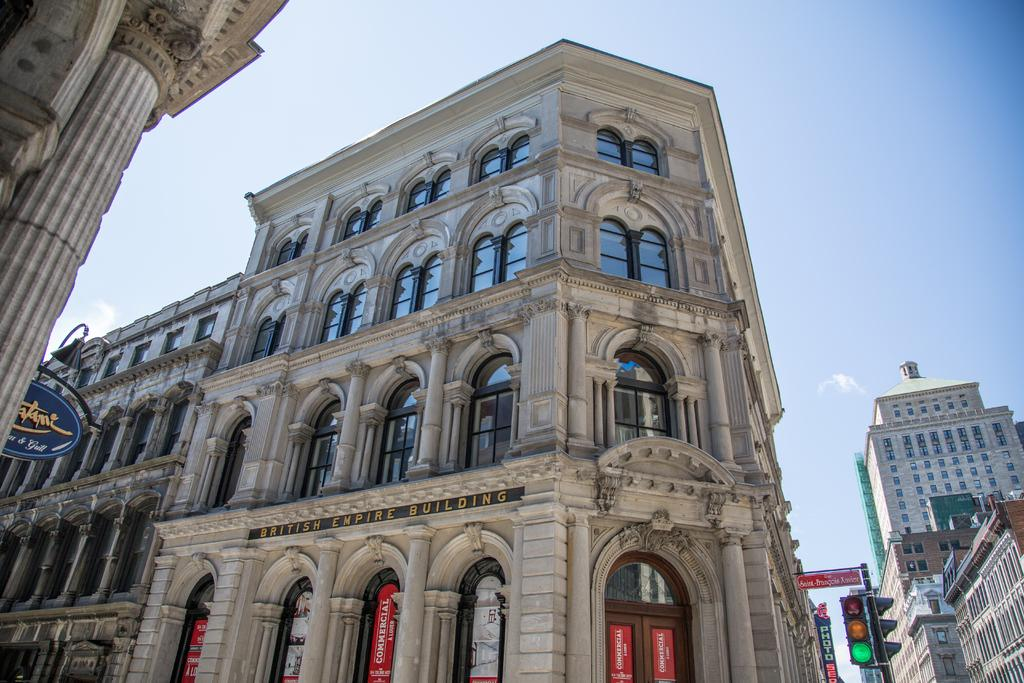What type of structures are present in the image? There are buildings in the image. What color are the buildings? The buildings are white in color. How tall are the buildings? The buildings are tall. What can be seen on the right side of the image? There are signals fixed to a pole on the right side of the image. What is visible in the background of the image? The sky is visible in the background of the image. Can you tell me the route the giraffe takes to reach the buildings in the image? There is no giraffe present in the image, so it is not possible to determine a route for one. 